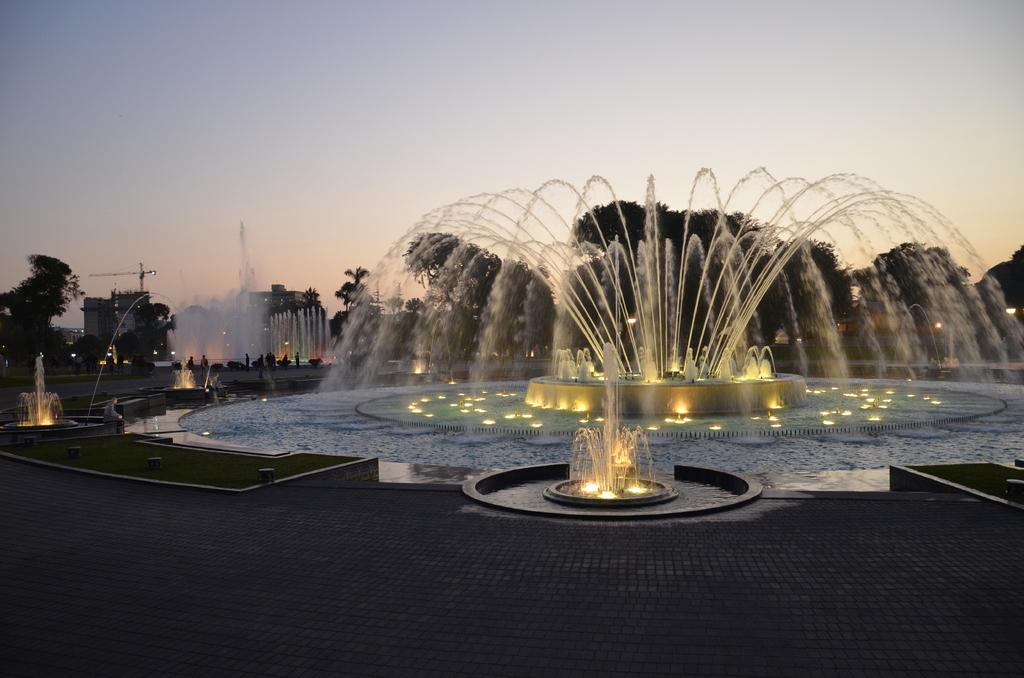What type of structures are present in the image? There are water fountains, trees, plants, buildings, and lights visible in the image. What type of vegetation can be seen in the image? There are trees and plants in the image, as well as grass. What is visible in the background of the image? The sky is visible in the background of the image. Where is the crate located in the image? There is no crate present in the image. What type of bird can be seen interacting with the water fountains in the image? There are no birds, including turkeys, present in the image. 